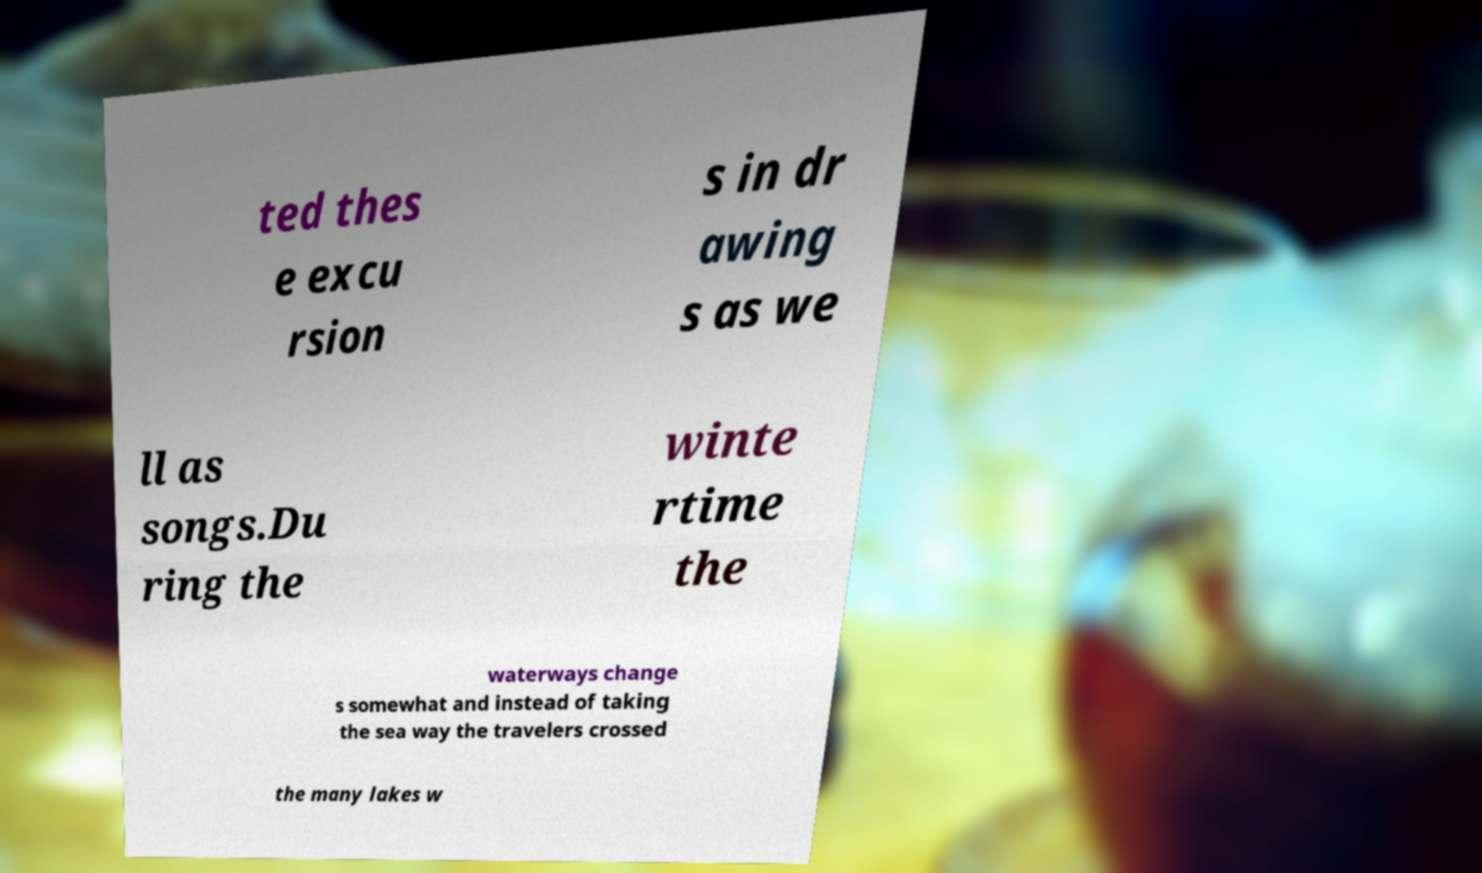There's text embedded in this image that I need extracted. Can you transcribe it verbatim? ted thes e excu rsion s in dr awing s as we ll as songs.Du ring the winte rtime the waterways change s somewhat and instead of taking the sea way the travelers crossed the many lakes w 